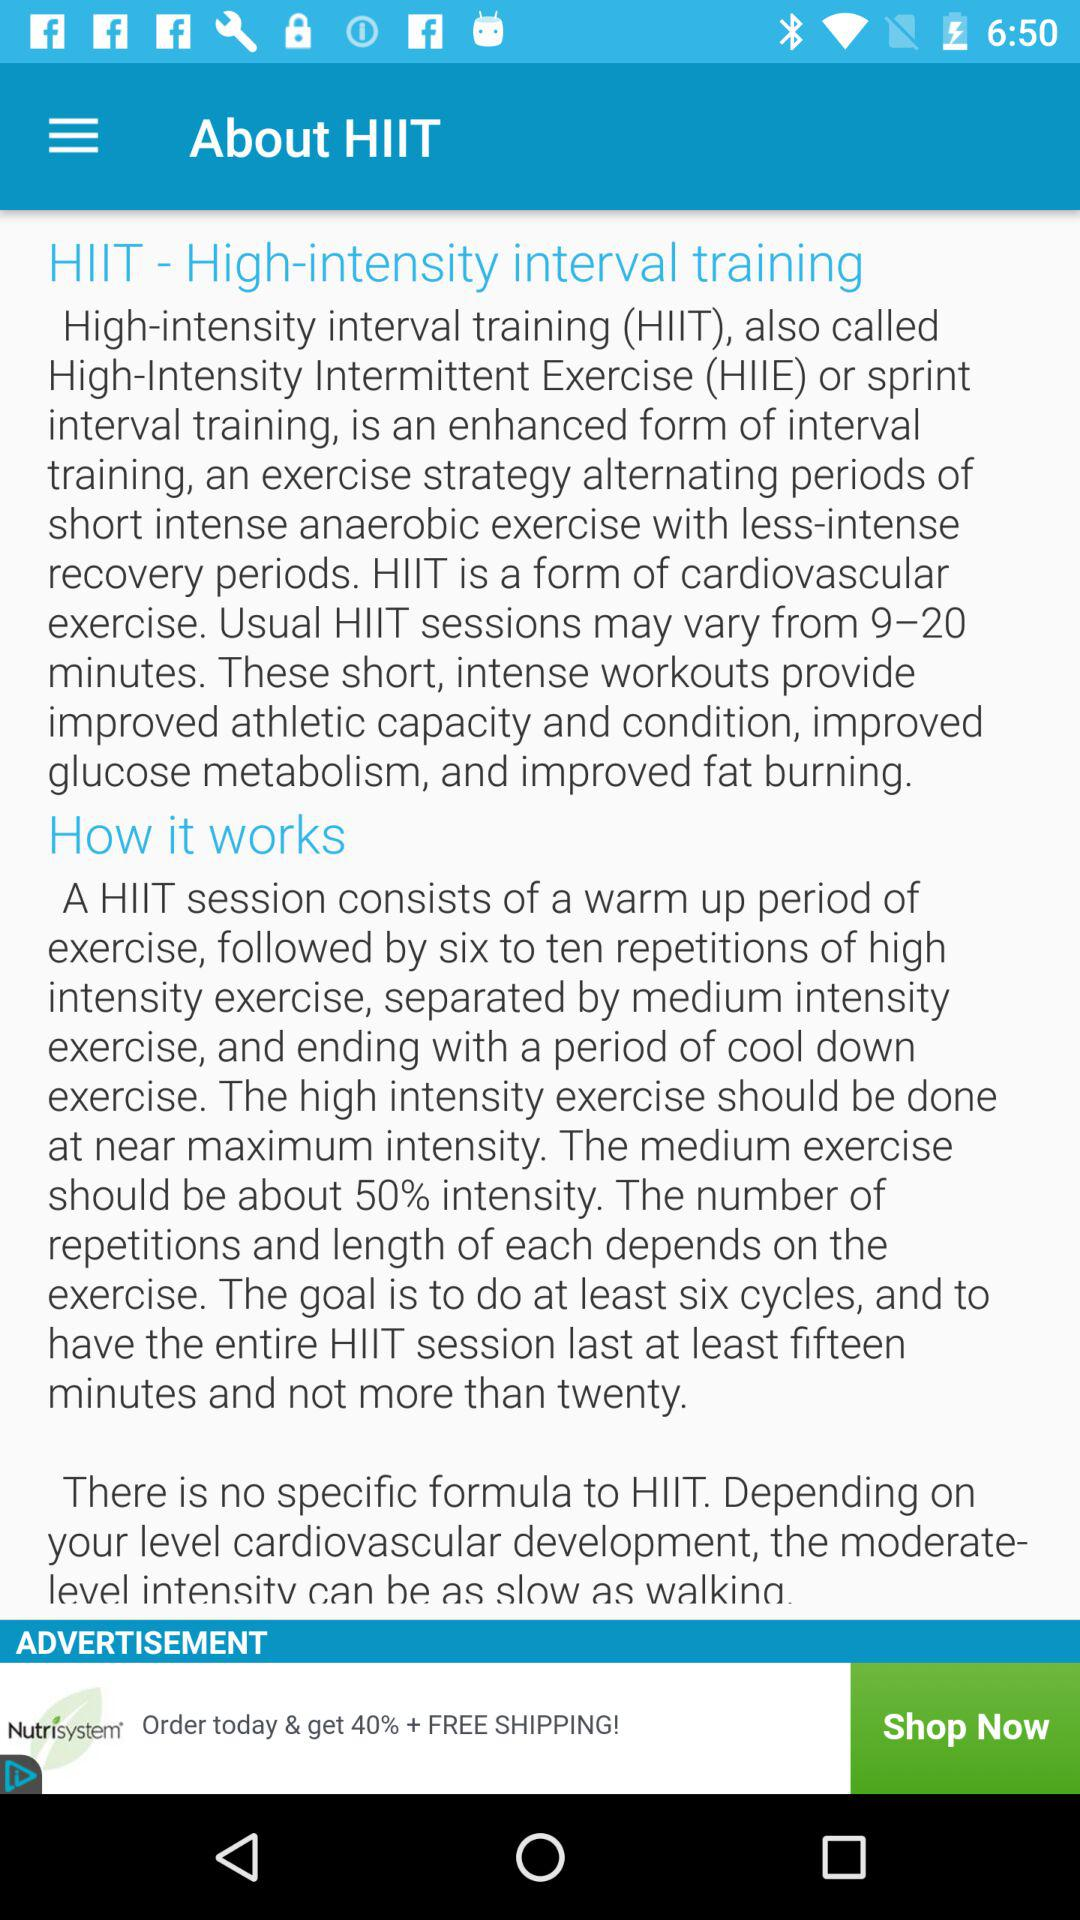What is the full form of HIIT? The full form of HIIT is High-intensity interval training. 